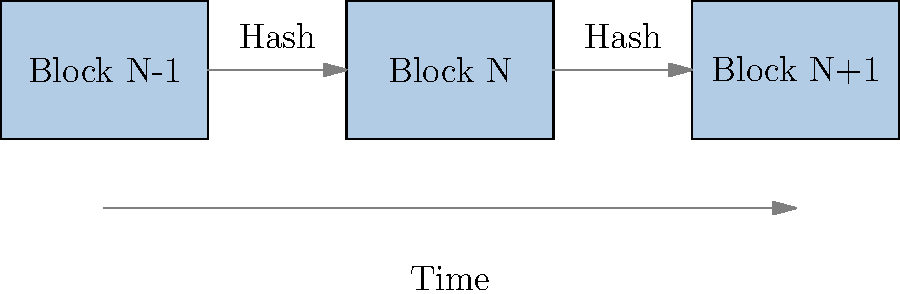In the simplified blockchain structure shown above, what critical information does each block typically contain to maintain the integrity and chronological order of the chain? To understand the structure of a blockchain and answer this question, let's break down the key elements:

1. Block Structure: The diagram shows three blocks (N-1, N, and N+1) connected in a chain.

2. Arrows between blocks: These represent the linkage between blocks, which is crucial for maintaining the chain's integrity.

3. "Hash" labels: These indicate that each block contains the hash of the previous block.

4. Time arrow: This shows that the blockchain progresses in chronological order.

The critical information each block contains to maintain integrity and chronological order is:

a) The hash of the previous block: This creates a cryptographic link between blocks, ensuring that any tampering with a previous block would be immediately detectable.

b) Timestamp: Although not explicitly shown in the diagram, the time arrow implies that each block includes a timestamp to maintain chronological order.

c) Transaction data: While not shown in this simplified diagram, each block typically contains a set of validated transactions.

d) Its own hash: Calculated based on all the block's contents, including the previous block's hash.

The combination of the previous block's hash and the current block's data (including timestamp) creates a chain that is both tamper-evident and maintains a clear chronological order. Any attempt to alter a block would change its hash, breaking the chain and making the alteration obvious.
Answer: Hash of the previous block and timestamp 